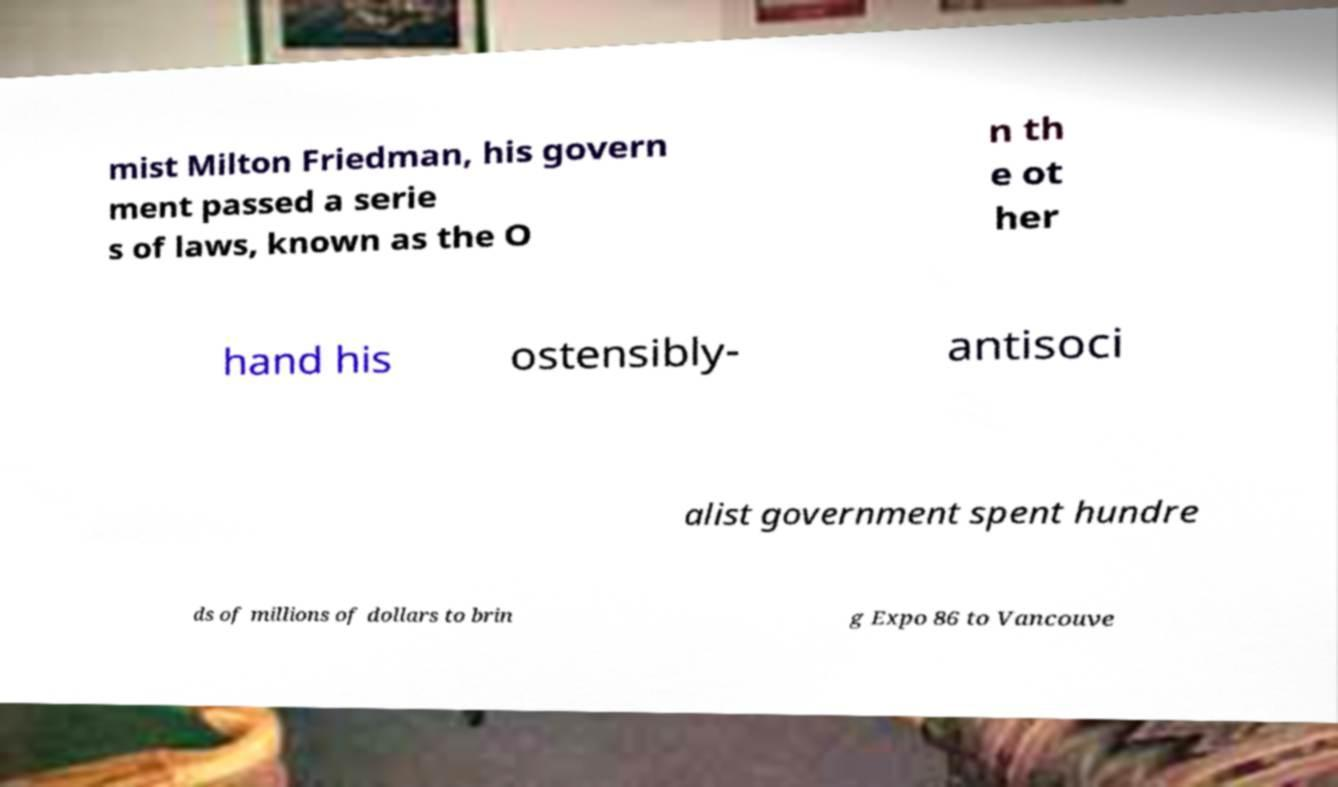Could you assist in decoding the text presented in this image and type it out clearly? mist Milton Friedman, his govern ment passed a serie s of laws, known as the O n th e ot her hand his ostensibly- antisoci alist government spent hundre ds of millions of dollars to brin g Expo 86 to Vancouve 